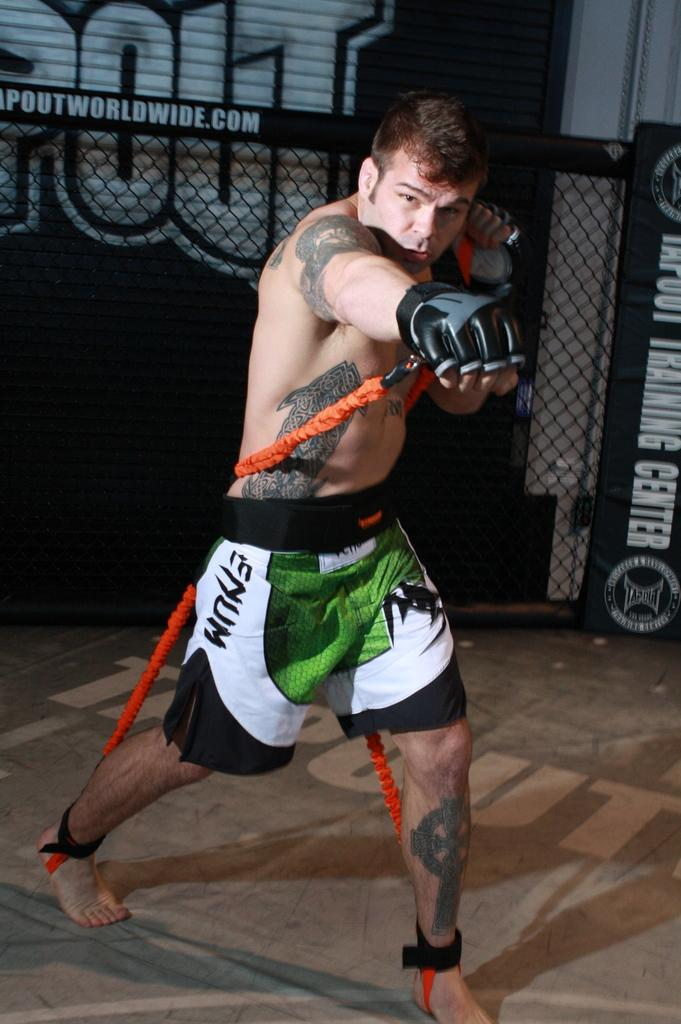<image>
Give a short and clear explanation of the subsequent image. The fighter is wearing green, white, and black shorts with the word ENUM. 